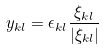<formula> <loc_0><loc_0><loc_500><loc_500>y _ { k l } = \epsilon _ { k l } \frac { \xi _ { k l } } { | \xi _ { k l } | }</formula> 